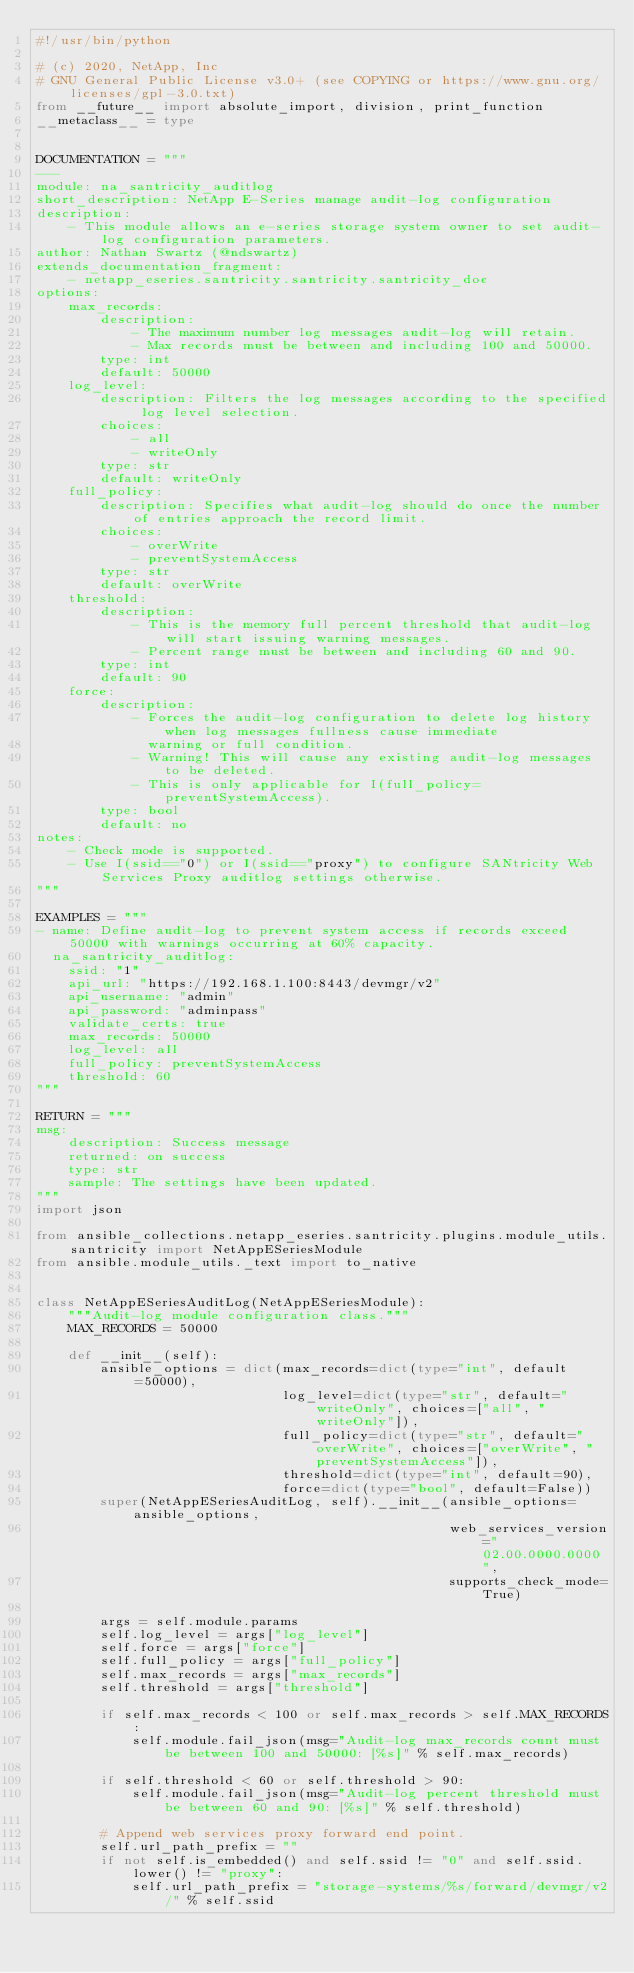Convert code to text. <code><loc_0><loc_0><loc_500><loc_500><_Python_>#!/usr/bin/python

# (c) 2020, NetApp, Inc
# GNU General Public License v3.0+ (see COPYING or https://www.gnu.org/licenses/gpl-3.0.txt)
from __future__ import absolute_import, division, print_function
__metaclass__ = type


DOCUMENTATION = """
---
module: na_santricity_auditlog
short_description: NetApp E-Series manage audit-log configuration
description:
    - This module allows an e-series storage system owner to set audit-log configuration parameters.
author: Nathan Swartz (@ndswartz)
extends_documentation_fragment:
    - netapp_eseries.santricity.santricity.santricity_doc
options:
    max_records:
        description:
            - The maximum number log messages audit-log will retain.
            - Max records must be between and including 100 and 50000.
        type: int
        default: 50000
    log_level:
        description: Filters the log messages according to the specified log level selection.
        choices:
            - all
            - writeOnly
        type: str
        default: writeOnly
    full_policy:
        description: Specifies what audit-log should do once the number of entries approach the record limit.
        choices:
            - overWrite
            - preventSystemAccess
        type: str
        default: overWrite
    threshold:
        description:
            - This is the memory full percent threshold that audit-log will start issuing warning messages.
            - Percent range must be between and including 60 and 90.
        type: int
        default: 90
    force:
        description:
            - Forces the audit-log configuration to delete log history when log messages fullness cause immediate
              warning or full condition.
            - Warning! This will cause any existing audit-log messages to be deleted.
            - This is only applicable for I(full_policy=preventSystemAccess).
        type: bool
        default: no
notes:
    - Check mode is supported.
    - Use I(ssid=="0") or I(ssid=="proxy") to configure SANtricity Web Services Proxy auditlog settings otherwise.
"""

EXAMPLES = """
- name: Define audit-log to prevent system access if records exceed 50000 with warnings occurring at 60% capacity.
  na_santricity_auditlog:
    ssid: "1"
    api_url: "https://192.168.1.100:8443/devmgr/v2"
    api_username: "admin"
    api_password: "adminpass"
    validate_certs: true
    max_records: 50000
    log_level: all
    full_policy: preventSystemAccess
    threshold: 60
"""

RETURN = """
msg:
    description: Success message
    returned: on success
    type: str
    sample: The settings have been updated.
"""
import json

from ansible_collections.netapp_eseries.santricity.plugins.module_utils.santricity import NetAppESeriesModule
from ansible.module_utils._text import to_native


class NetAppESeriesAuditLog(NetAppESeriesModule):
    """Audit-log module configuration class."""
    MAX_RECORDS = 50000

    def __init__(self):
        ansible_options = dict(max_records=dict(type="int", default=50000),
                               log_level=dict(type="str", default="writeOnly", choices=["all", "writeOnly"]),
                               full_policy=dict(type="str", default="overWrite", choices=["overWrite", "preventSystemAccess"]),
                               threshold=dict(type="int", default=90),
                               force=dict(type="bool", default=False))
        super(NetAppESeriesAuditLog, self).__init__(ansible_options=ansible_options,
                                                    web_services_version="02.00.0000.0000",
                                                    supports_check_mode=True)

        args = self.module.params
        self.log_level = args["log_level"]
        self.force = args["force"]
        self.full_policy = args["full_policy"]
        self.max_records = args["max_records"]
        self.threshold = args["threshold"]

        if self.max_records < 100 or self.max_records > self.MAX_RECORDS:
            self.module.fail_json(msg="Audit-log max_records count must be between 100 and 50000: [%s]" % self.max_records)

        if self.threshold < 60 or self.threshold > 90:
            self.module.fail_json(msg="Audit-log percent threshold must be between 60 and 90: [%s]" % self.threshold)

        # Append web services proxy forward end point.
        self.url_path_prefix = ""
        if not self.is_embedded() and self.ssid != "0" and self.ssid.lower() != "proxy":
            self.url_path_prefix = "storage-systems/%s/forward/devmgr/v2/" % self.ssid
</code> 